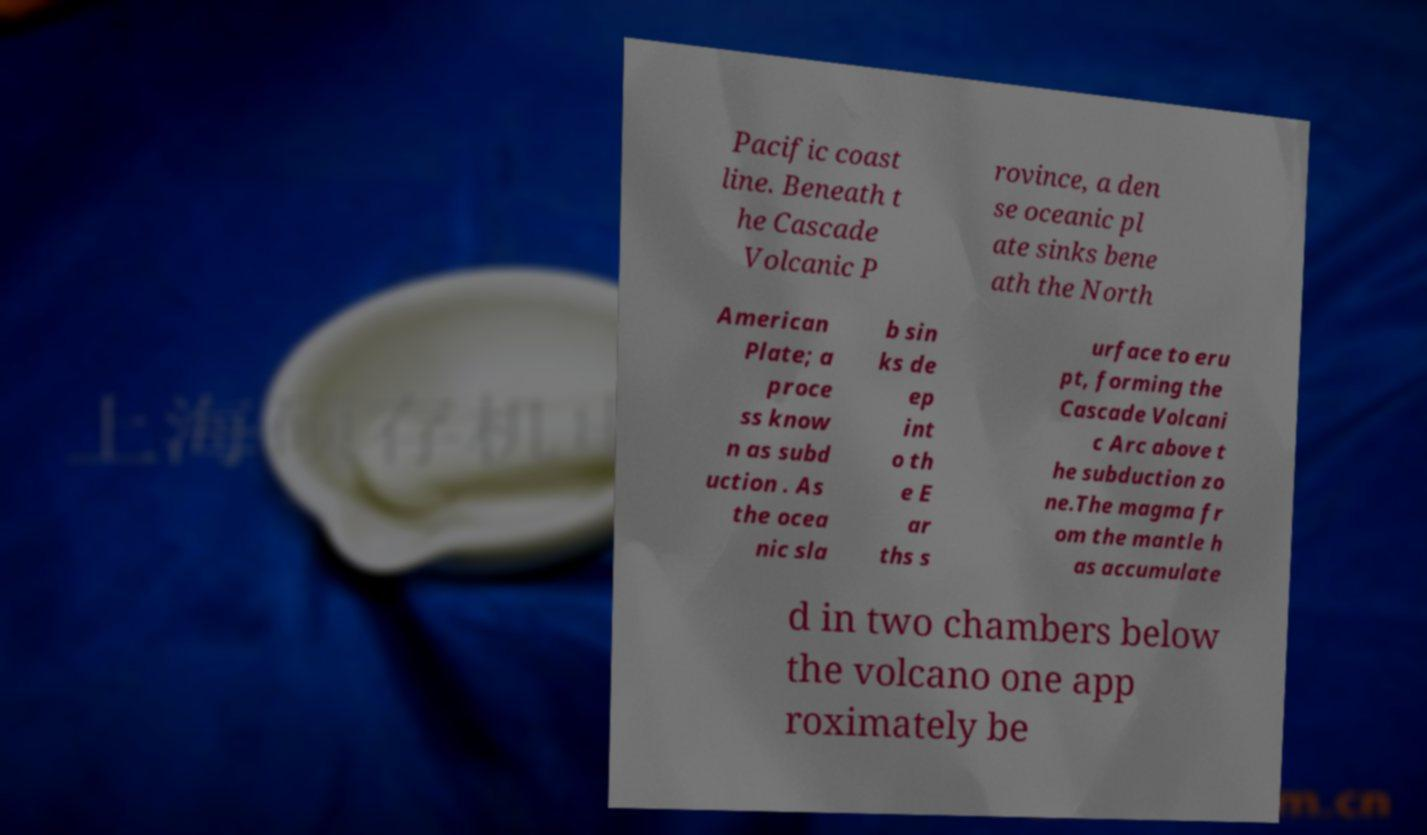Please read and relay the text visible in this image. What does it say? Pacific coast line. Beneath t he Cascade Volcanic P rovince, a den se oceanic pl ate sinks bene ath the North American Plate; a proce ss know n as subd uction . As the ocea nic sla b sin ks de ep int o th e E ar ths s urface to eru pt, forming the Cascade Volcani c Arc above t he subduction zo ne.The magma fr om the mantle h as accumulate d in two chambers below the volcano one app roximately be 